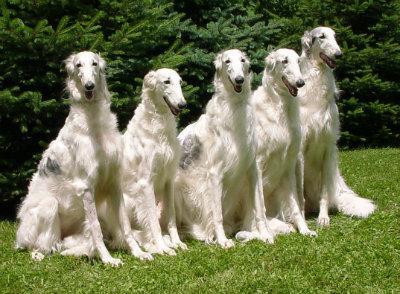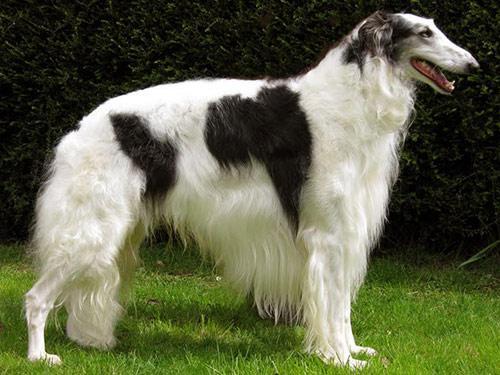The first image is the image on the left, the second image is the image on the right. For the images displayed, is the sentence "There is only one dog in each picture." factually correct? Answer yes or no. No. 